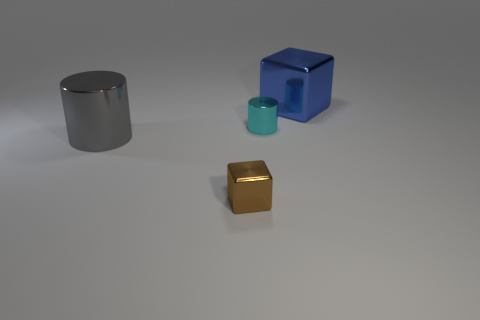What time of day does this scene represent? Given the absence of any distinct shadows or indications of natural light, this scene might not represent a specific time of day. It seems to be an indoor setting with controlled lighting. 